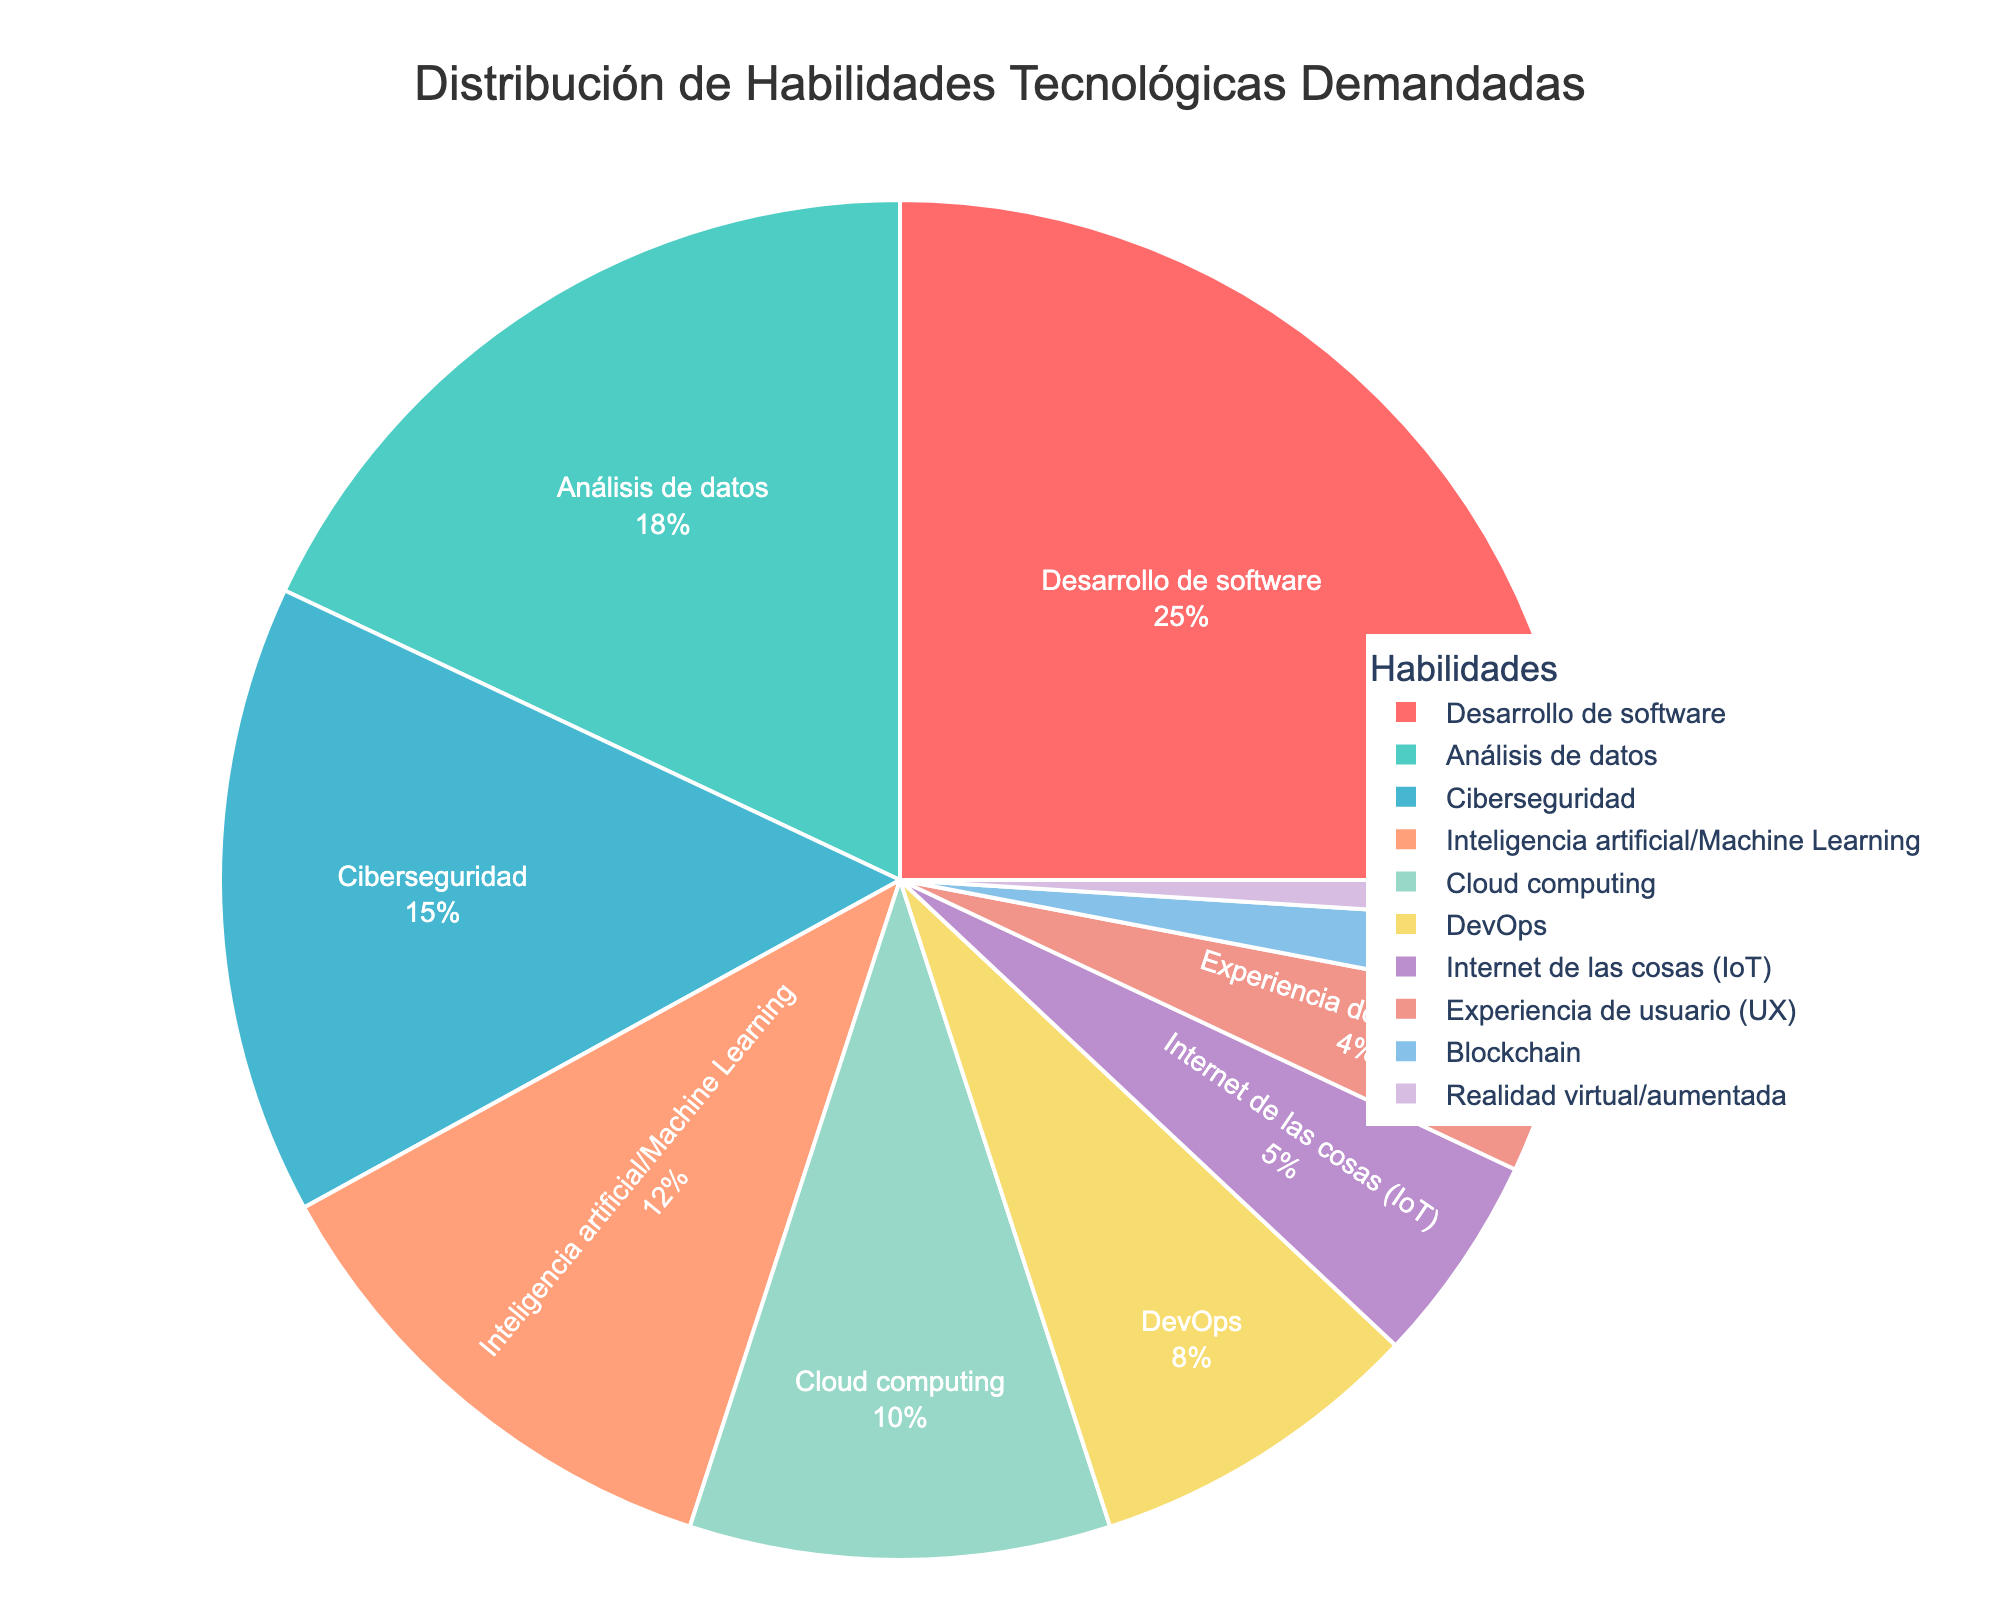What's the top skill in demand? The segment with the largest percentage represents the top skill. Here, "Desarrollo de software" has the largest slice of the pie chart at 25%.
Answer: Desarrollo de software Which skill is less in demand than Cloud computing but more in demand than Blockchain? We need to locate the segments representing "Cloud computing" (10%) and "Blockchain" (2%). The skill falling between these percentages is "DevOps" at 8%.
Answer: DevOps What is the combined percentage of the top three skills? The top three skills are "Desarrollo de software" (25%), "Análisis de datos" (18%), and "Ciberseguridad" (15%). Summing these percentages: 25% + 18% + 15% = 58%.
Answer: 58% How much higher is the demand for "DevOps" compared to "Internet de las cosas (IoT)"? "DevOps" is at 8%, and "Internet de las cosas (IoT)" is at 5%. The difference is calculated as 8% - 5% = 3%.
Answer: 3% Which skill has the smallest demand? The segment with the smallest percentage represents the skill with the smallest demand. Here, "Realidad virtual/aumentada" has the smallest slice at 1%.
Answer: Realidad virtual/aumentada How does the demand for "Experiencia de usuario (UX)" compare to "Ciberseguridad"? "Experiencia de usuario (UX)" has a 4% share, whereas "Ciberseguridad" has a 15% share. "Ciberseguridad" is clearly larger.
Answer: Ciberseguridad What is the combined share of "Inteligencia artificial/Machine Learning" and "Cloud computing"? "Inteligencia artificial/Machine Learning" has 12%, and "Cloud computing" has 10%. Summing these percentages: 12% + 10% = 22%.
Answer: 22% By how much does the demand for "Desarrollo de software" exceed that for "Análisis de datos"? "Desarrollo de software" is at 25%, and "Análisis de datos" is at 18%. The difference is calculated as 25% - 18% = 7%.
Answer: 7% Which skill has a demand very close to "DevOps" but slightly less? "DevOps" has 8%, and the closest skill with slightly less demand is "Cloud computing" at 10%.
Answer: Internet de las cosas (IoT) What's the total percentage of skills with a demand of 4% or lower? Skills with 4% or lower are "Experiencia de usuario (UX)" (4%), "Blockchain" (2%), and "Realidad virtual/aumentada" (1%). Summing these percentages: 4% + 2% + 1% = 7%.
Answer: 7% 